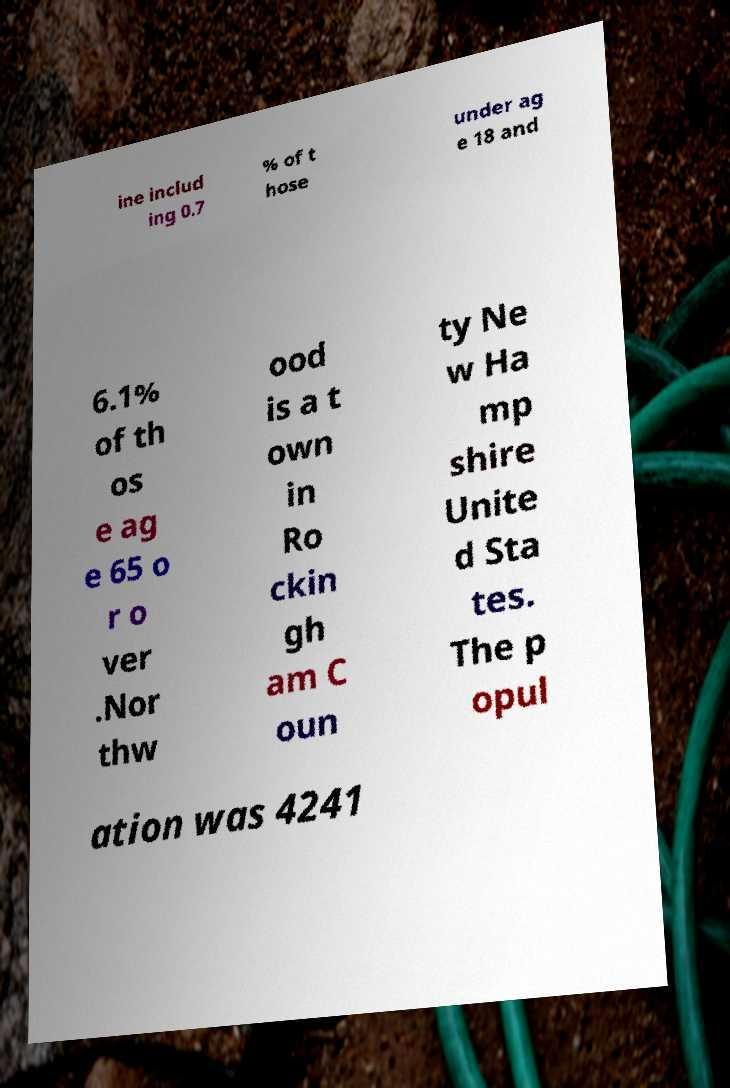Please read and relay the text visible in this image. What does it say? ine includ ing 0.7 % of t hose under ag e 18 and 6.1% of th os e ag e 65 o r o ver .Nor thw ood is a t own in Ro ckin gh am C oun ty Ne w Ha mp shire Unite d Sta tes. The p opul ation was 4241 